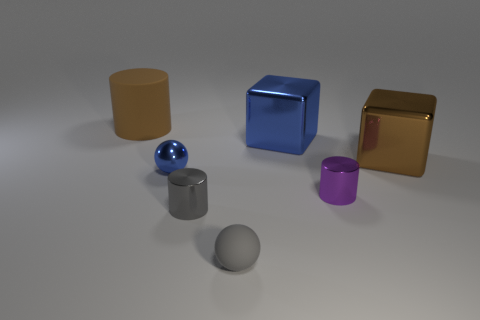Subtract all big cylinders. How many cylinders are left? 2 Add 3 tiny blue balls. How many objects exist? 10 Subtract all blue spheres. How many spheres are left? 1 Subtract all spheres. How many objects are left? 5 Subtract 2 cylinders. How many cylinders are left? 1 Subtract all gray cylinders. Subtract all yellow balls. How many cylinders are left? 2 Subtract all large shiny objects. Subtract all metallic objects. How many objects are left? 0 Add 3 brown blocks. How many brown blocks are left? 4 Add 1 large purple objects. How many large purple objects exist? 1 Subtract 0 yellow cylinders. How many objects are left? 7 